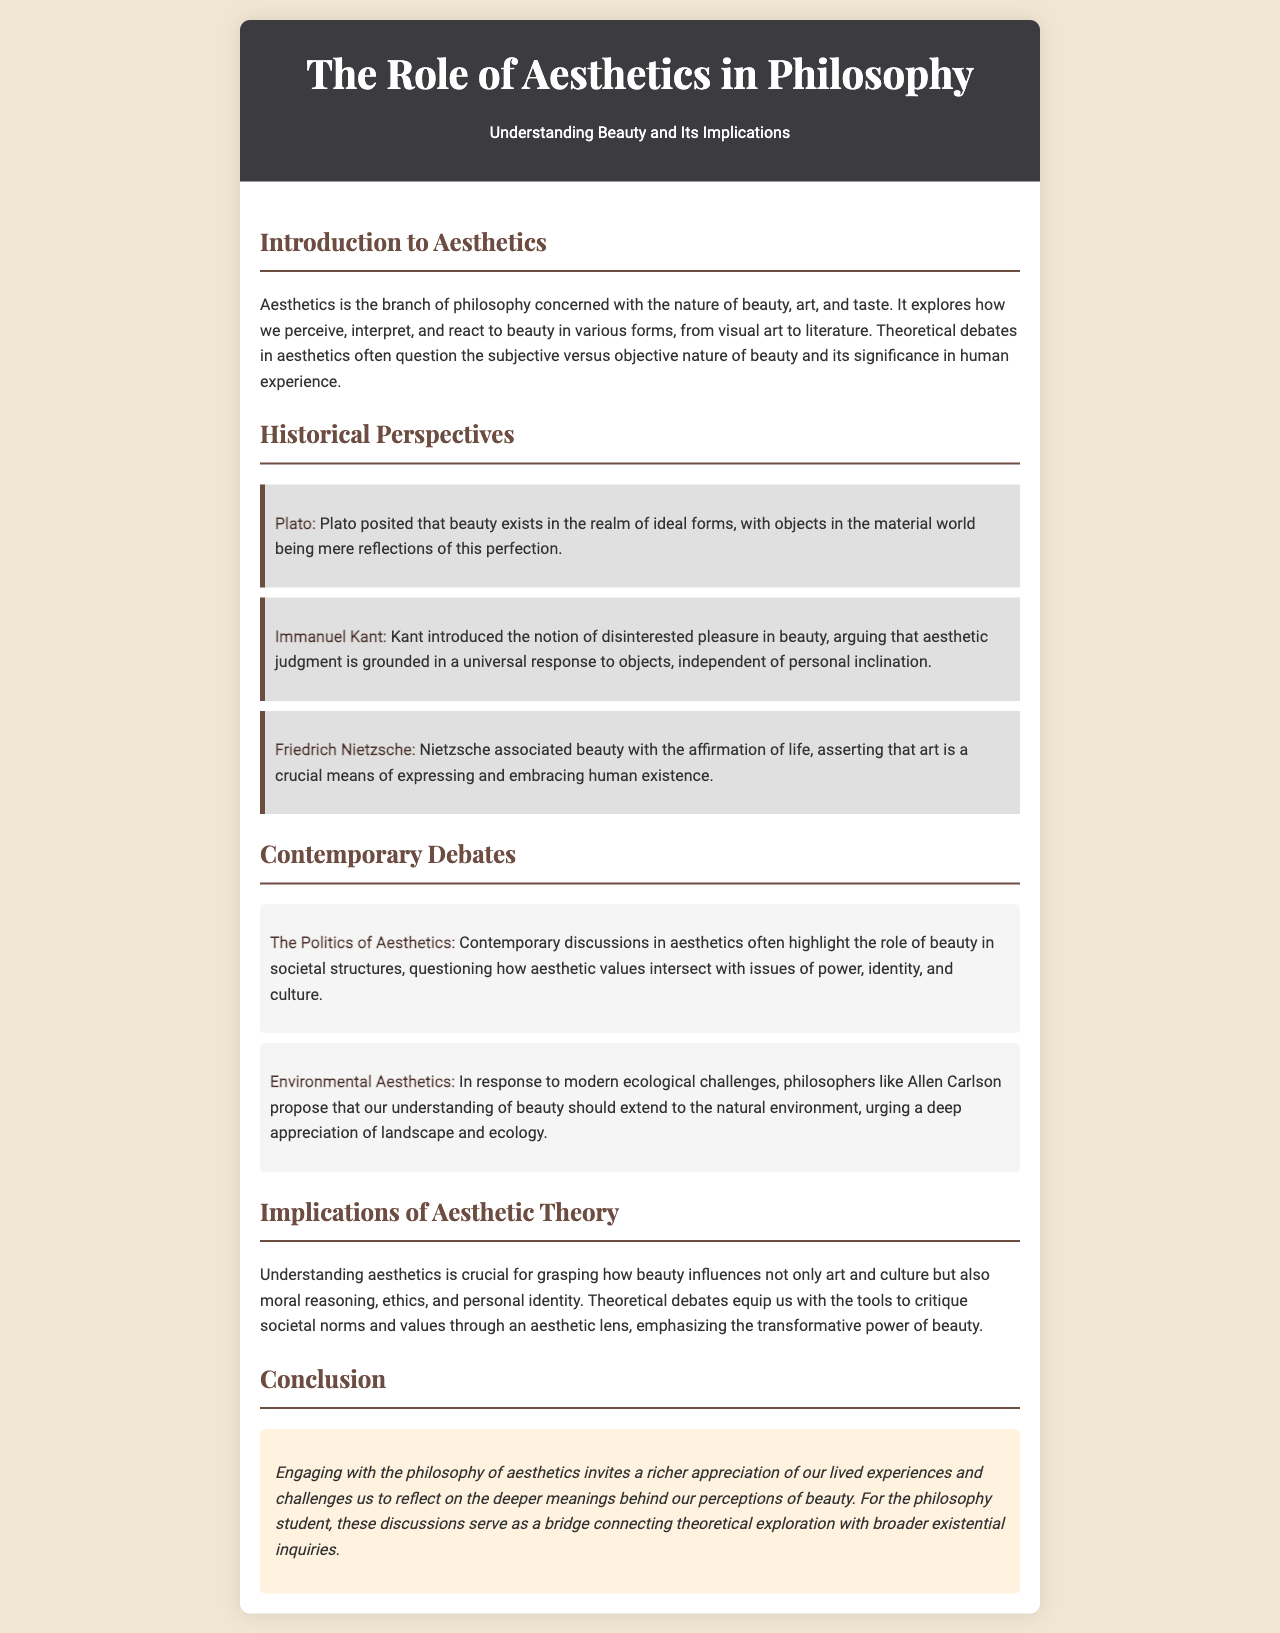What is the title of the brochure? The title of the brochure as indicated in the header is "The Role of Aesthetics in Philosophy."
Answer: The Role of Aesthetics in Philosophy Who introduced the notion of disinterested pleasure in beauty? The document mentions that Immanuel Kant introduced the notion of disinterested pleasure in beauty in the Historical Perspectives section.
Answer: Immanuel Kant What is a key theme discussed in contemporary aesthetics? The document lists several contemporary themes, one being "The Politics of Aesthetics."
Answer: The Politics of Aesthetics Which philosopher associated beauty with the affirmation of life? According to the Historical Perspectives section, Friedrich Nietzsche associated beauty with the affirmation of life.
Answer: Friedrich Nietzsche What is the importance of aesthetics according to the document? The document states that understanding aesthetics is crucial for grasping the influence of beauty on various aspects, including moral reasoning and ethics.
Answer: Moral reasoning What color is the background of the brochure? The background color of the brochure as described in the CSS styles is a light beige color (#f0e6d2).
Answer: Light beige What does the conclusion emphasize? The conclusion emphasizes the invitation to reflect on deeper meanings behind perceptions of beauty within existential inquiries.
Answer: Deeper meanings What type of art forms does aesthetics explore? The introduction states that aesthetics explores various forms, from visual art to literature.
Answer: Visual art and literature 